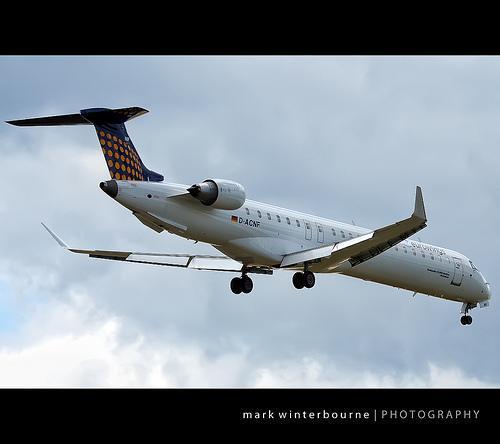How many planes are in the sky?
Give a very brief answer. 1. How many wings are on the plane?
Give a very brief answer. 2. 